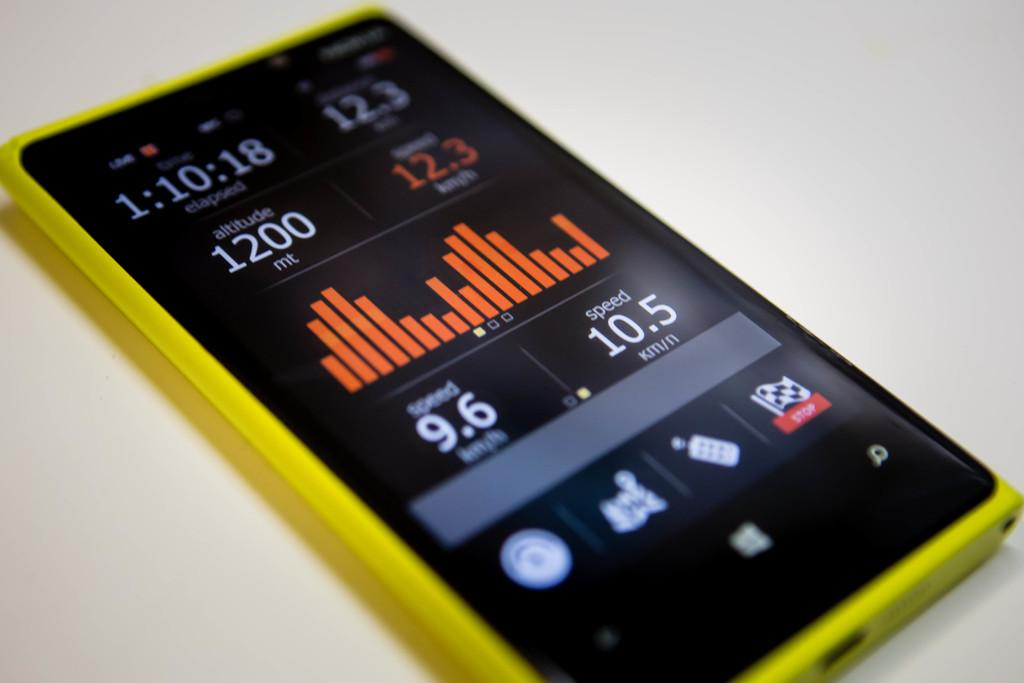What object can be seen in the image? There is a phone in the image. What is the color of the surface the phone is on? The phone is on a white surface. What can be seen on the screen of the phone? There is information visible on a screen. What type of animal can be seen swimming in the background of the image? There are no animals or background visible in the image; it only features a phone on a white surface with information on the screen. 